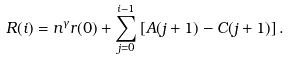<formula> <loc_0><loc_0><loc_500><loc_500>R ( i ) & = n ^ { \gamma } r ( 0 ) + \sum _ { j = 0 } ^ { i - 1 } \left [ A ( j + 1 ) - C ( j + 1 ) \right ] .</formula> 